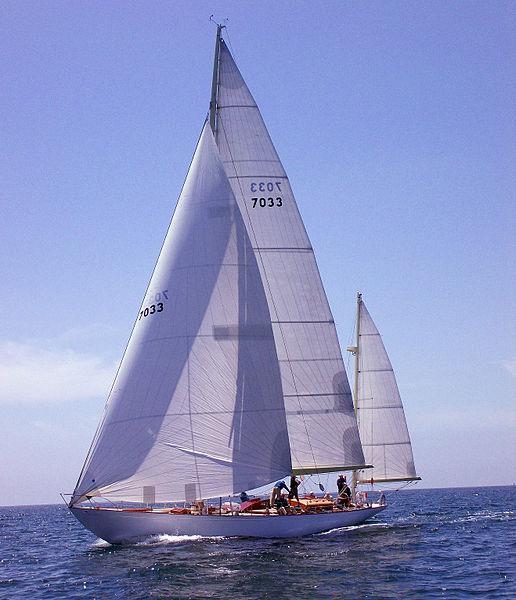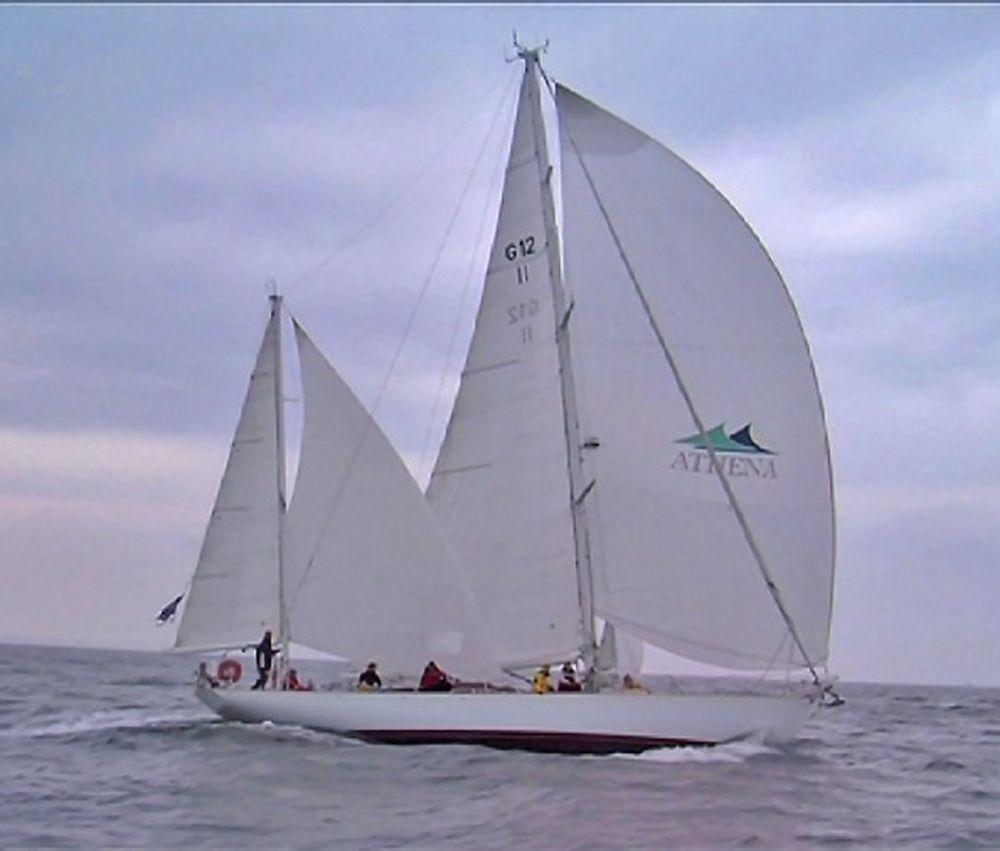The first image is the image on the left, the second image is the image on the right. Analyze the images presented: Is the assertion "All sailboats have three sails unfurled." valid? Answer yes or no. No. 